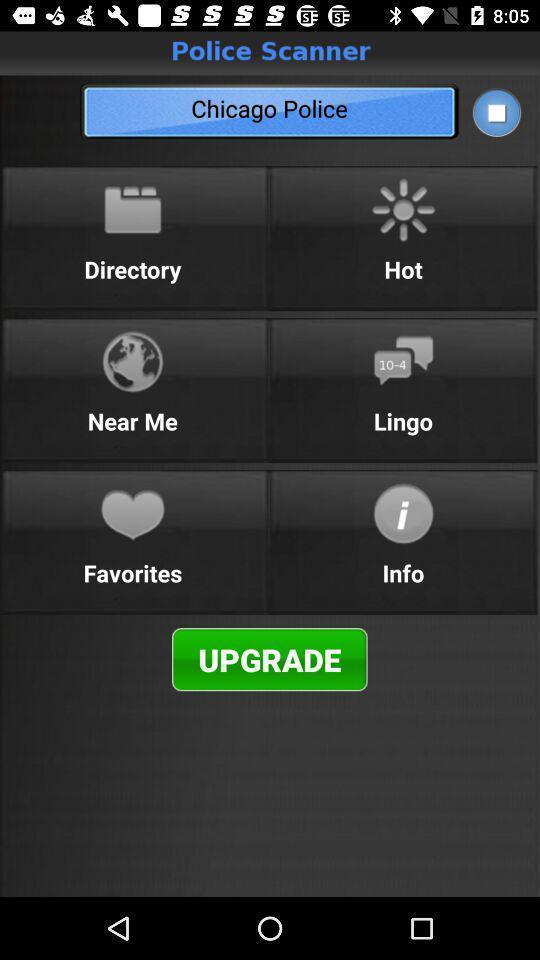Summarize the information in this screenshot. Menu page of police scanner. 